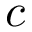<formula> <loc_0><loc_0><loc_500><loc_500>c</formula> 